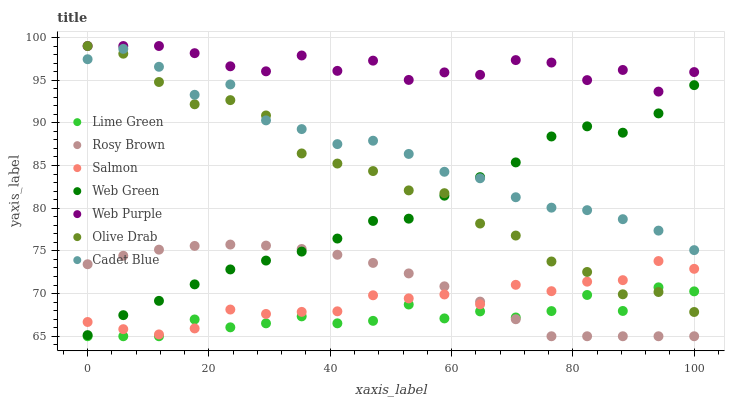Does Lime Green have the minimum area under the curve?
Answer yes or no. Yes. Does Web Purple have the maximum area under the curve?
Answer yes or no. Yes. Does Rosy Brown have the minimum area under the curve?
Answer yes or no. No. Does Rosy Brown have the maximum area under the curve?
Answer yes or no. No. Is Rosy Brown the smoothest?
Answer yes or no. Yes. Is Web Purple the roughest?
Answer yes or no. Yes. Is Salmon the smoothest?
Answer yes or no. No. Is Salmon the roughest?
Answer yes or no. No. Does Rosy Brown have the lowest value?
Answer yes or no. Yes. Does Salmon have the lowest value?
Answer yes or no. No. Does Olive Drab have the highest value?
Answer yes or no. Yes. Does Rosy Brown have the highest value?
Answer yes or no. No. Is Lime Green less than Web Green?
Answer yes or no. Yes. Is Web Purple greater than Cadet Blue?
Answer yes or no. Yes. Does Rosy Brown intersect Lime Green?
Answer yes or no. Yes. Is Rosy Brown less than Lime Green?
Answer yes or no. No. Is Rosy Brown greater than Lime Green?
Answer yes or no. No. Does Lime Green intersect Web Green?
Answer yes or no. No. 